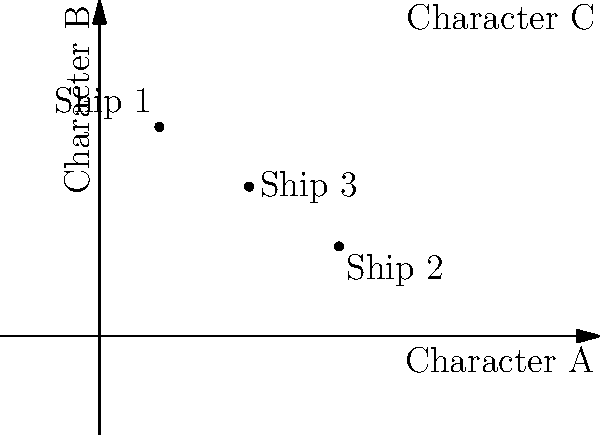In a love triangle coordinate system where the axes represent Character A and Character B, and the top right corner represents Character C, three popular "ships" (fan-favorite romantic pairings) are plotted. Which ship appears to have the most balanced relationship between all three characters? To determine which ship has the most balanced relationship between all three characters, we need to analyze the position of each plotted point:

1. Ship 1 (0.2, 0.7): This point is closer to the Character B axis and relatively far from the Character A axis. It's also closer to Character C than to Character A.

2. Ship 2 (0.8, 0.3): This point is closer to the Character A axis and relatively far from the Character B axis. It's also closer to Character A than to Character C.

3. Ship 3 (0.5, 0.5): This point is equidistant from both the Character A and Character B axes. It's also equidistant from the origin (representing a balanced relationship between A and B) and the top right corner (representing Character C).

The most balanced relationship would be represented by a point that is equally distant from all three characters. In this case, Ship 3 (0.5, 0.5) is the closest to achieving this balance, as it sits at the midpoint between Characters A and B, and is equidistant from the origin and Character C's position.
Answer: Ship 3 